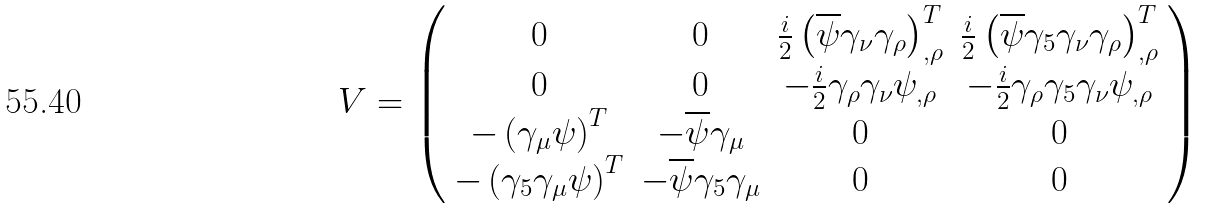Convert formula to latex. <formula><loc_0><loc_0><loc_500><loc_500>V = \left ( \begin{array} { c c c c } 0 & 0 & \frac { i } { 2 } \left ( \overline { \psi } \gamma _ { \nu } \gamma _ { \rho } \right ) ^ { T } _ { , \rho } & \frac { i } { 2 } \left ( \overline { \psi } \gamma _ { 5 } \gamma _ { \nu } \gamma _ { \rho } \right ) ^ { T } _ { , \rho } \\ 0 & 0 & - \frac { i } { 2 } \gamma _ { \rho } \gamma _ { \nu } \psi _ { , \rho } & - \frac { i } { 2 } \gamma _ { \rho } \gamma _ { 5 } \gamma _ { \nu } \psi _ { , \rho } \\ - \left ( \gamma _ { \mu } \psi \right ) ^ { T } & - \overline { \psi } \gamma _ { \mu } & 0 & 0 \\ - \left ( \gamma _ { 5 } \gamma _ { \mu } \psi \right ) ^ { T } & - \overline { \psi } \gamma _ { 5 } \gamma _ { \mu } & 0 & 0 \end{array} \right )</formula> 